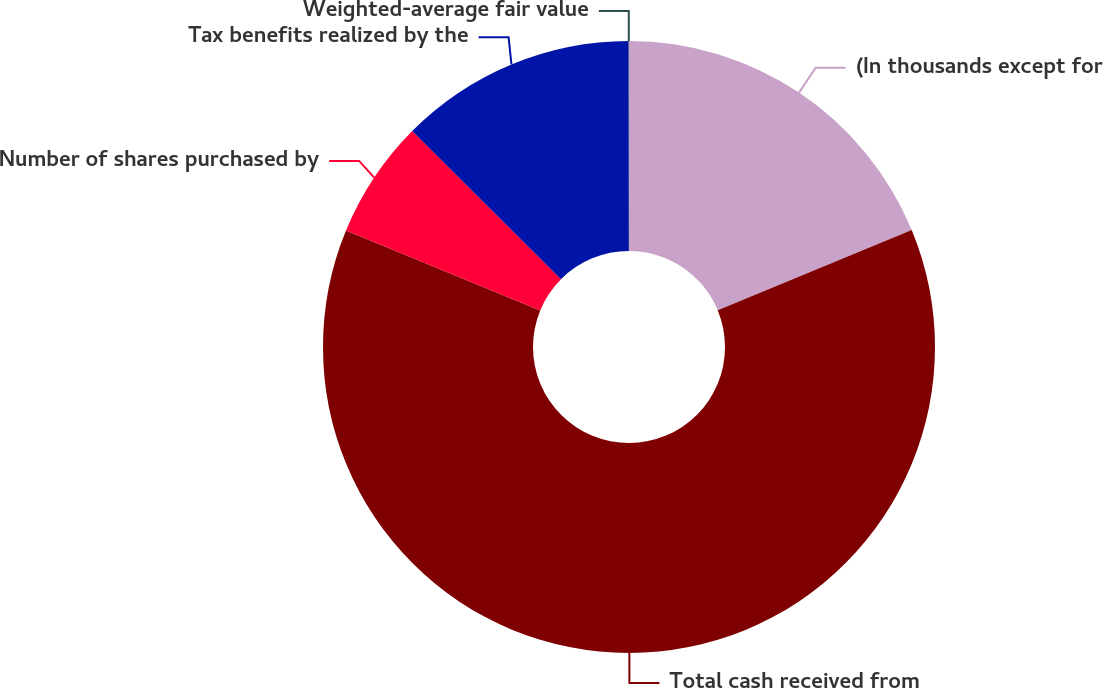Convert chart to OTSL. <chart><loc_0><loc_0><loc_500><loc_500><pie_chart><fcel>(In thousands except for<fcel>Total cash received from<fcel>Number of shares purchased by<fcel>Tax benefits realized by the<fcel>Weighted-average fair value<nl><fcel>18.75%<fcel>62.46%<fcel>6.26%<fcel>12.51%<fcel>0.02%<nl></chart> 